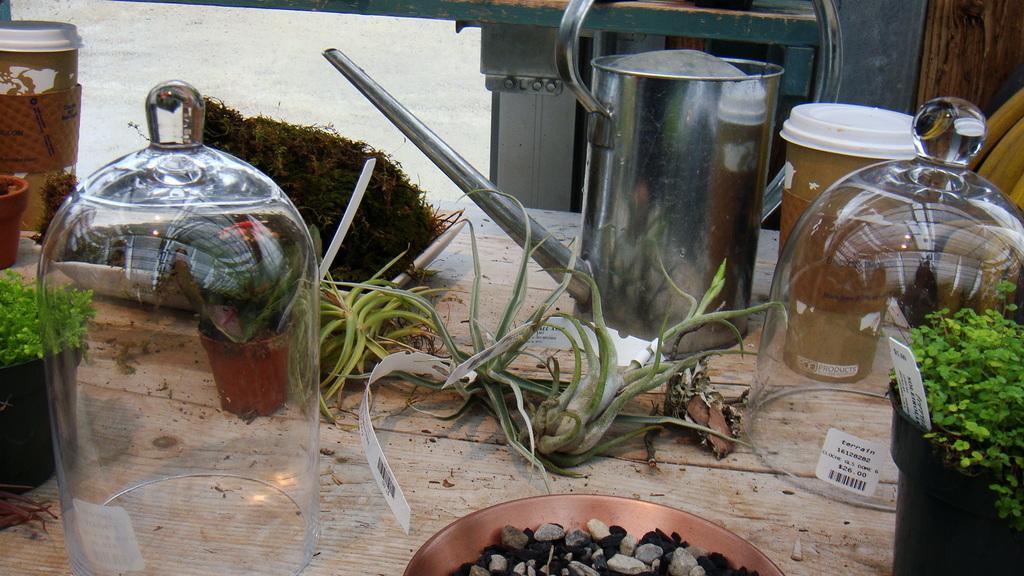Could you give a brief overview of what you see in this image? There is a wooden table. On that there are glass containers, kettle, planter, plate with stones, pots with plants. Also many other items. 